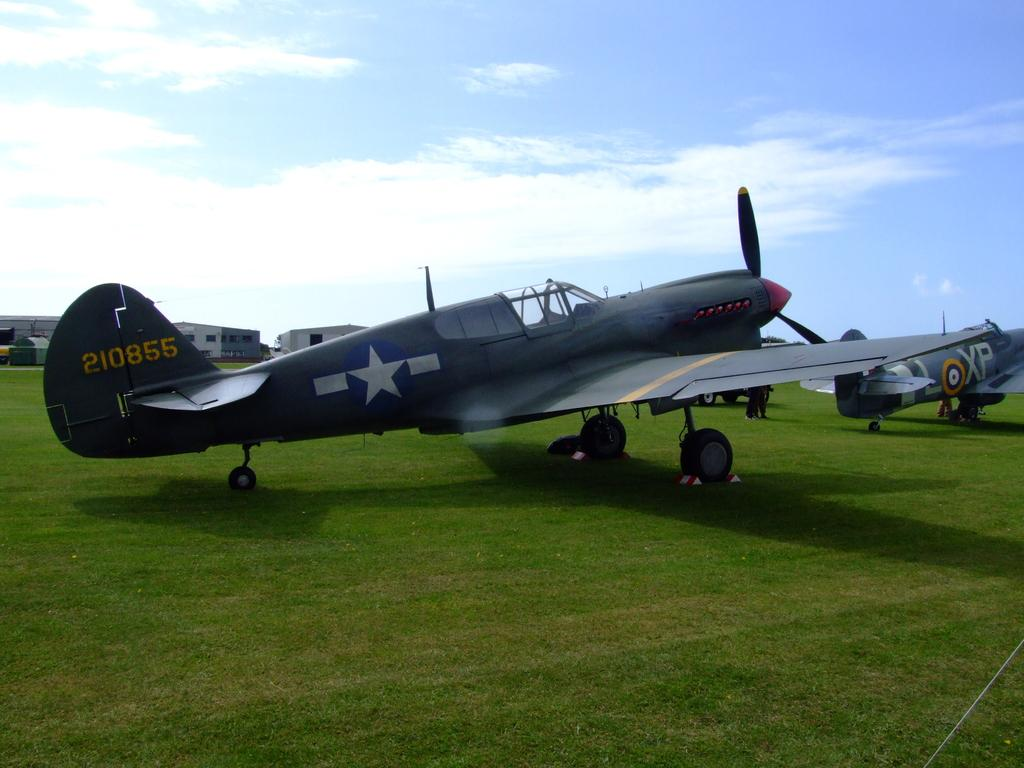Provide a one-sentence caption for the provided image. Aircraft 210855 sits on a field among other similar planes. 